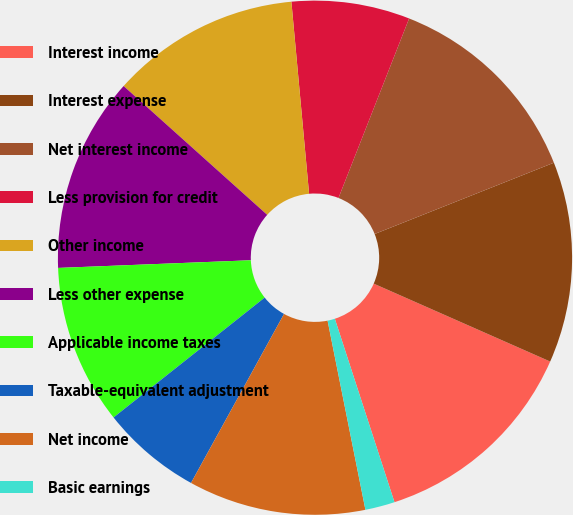Convert chart to OTSL. <chart><loc_0><loc_0><loc_500><loc_500><pie_chart><fcel>Interest income<fcel>Interest expense<fcel>Net interest income<fcel>Less provision for credit<fcel>Other income<fcel>Less other expense<fcel>Applicable income taxes<fcel>Taxable-equivalent adjustment<fcel>Net income<fcel>Basic earnings<nl><fcel>13.38%<fcel>12.64%<fcel>13.01%<fcel>7.43%<fcel>11.9%<fcel>12.27%<fcel>10.04%<fcel>6.32%<fcel>11.15%<fcel>1.86%<nl></chart> 